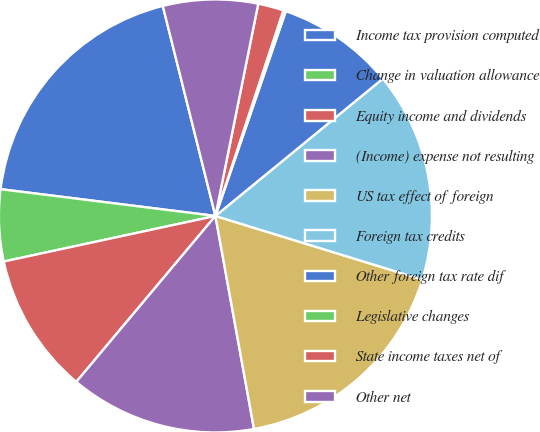Convert chart to OTSL. <chart><loc_0><loc_0><loc_500><loc_500><pie_chart><fcel>Income tax provision computed<fcel>Change in valuation allowance<fcel>Equity income and dividends<fcel>(Income) expense not resulting<fcel>US tax effect of foreign<fcel>Foreign tax credits<fcel>Other foreign tax rate dif<fcel>Legislative changes<fcel>State income taxes net of<fcel>Other net<nl><fcel>19.12%<fcel>5.35%<fcel>10.52%<fcel>13.96%<fcel>17.4%<fcel>15.68%<fcel>8.8%<fcel>0.19%<fcel>1.91%<fcel>7.08%<nl></chart> 